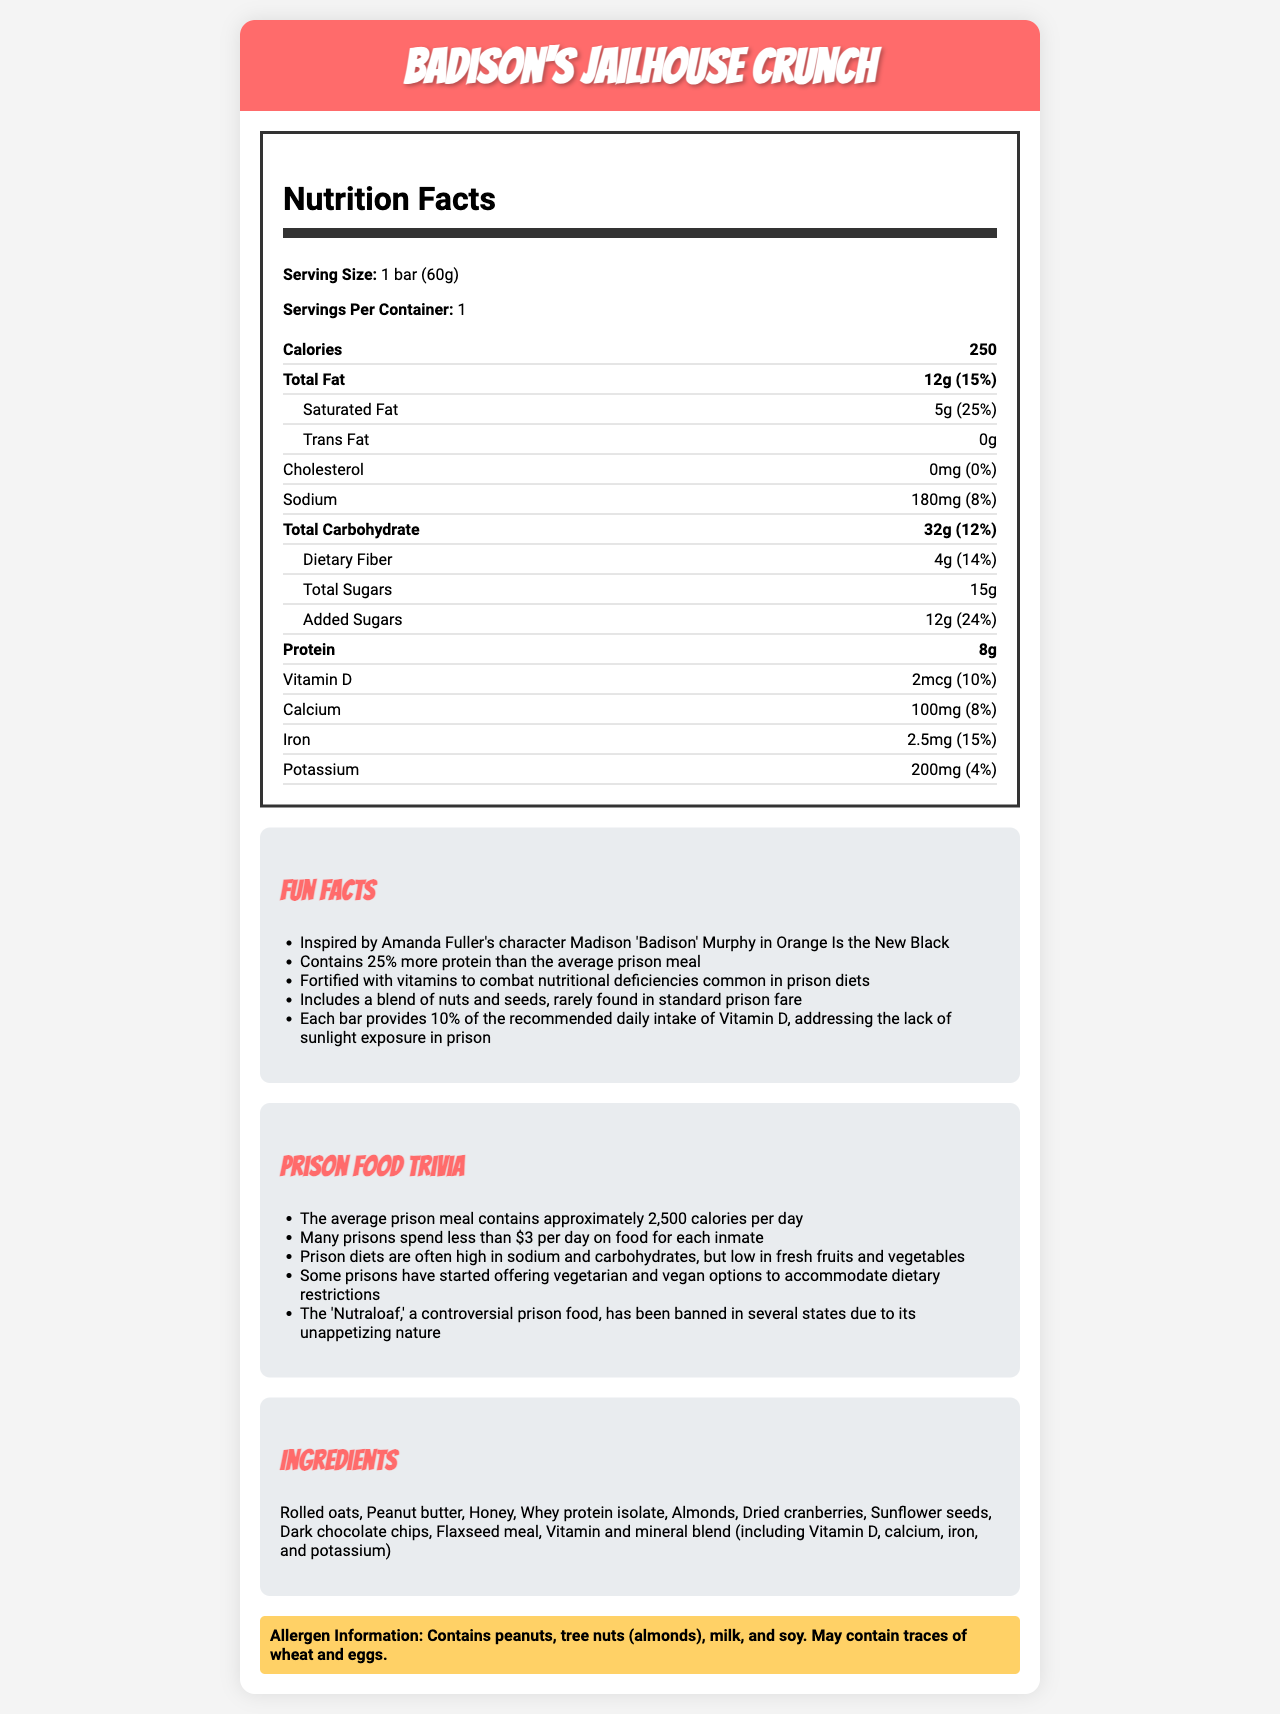what is the serving size of Badison's Jailhouse Crunch? The document states that the serving size is "1 bar (60g)".
Answer: 1 bar (60g) how many calories does each bar of Badison's Jailhouse Crunch have? The nutrition facts section lists the calorie content as 250.
Answer: 250 what percentage of the daily value is the saturated fat content? The nutrition facts indicate that the saturated fat content is 5g, which is 25% of the daily value.
Answer: 25% which ingredient is mentioned first in the ingredient list? The ingredients section lists "Rolled oats" first.
Answer: Rolled oats does Badison's Jailhouse Crunch contain any allergens? The allergen information at the end of the document states that it contains peanuts, tree nuts (almonds), milk, and soy.
Answer: Yes how much dietary fiber is in each serving? The document notes that each serving contains 4g of dietary fiber.
Answer: 4g which nutrient is present in the highest amount per serving: sodium, calcium, or potassium? According to the nutrition facts, sodium amounts to 180mg, whereas calcium is 100mg and potassium is 200mg. The explanation would be incorrect, Potassium is higher).
Answer: Sodium how much of the daily value of vitamin D does each bar provide? The nutrition facts indicate that each bar provides 2mcg of Vitamin D, equivalent to 10% of the daily value.
Answer: 10% what type of fats are absent in Badison's Jailhouse Crunch? The nutrition facts specifically state that there are 0g of trans fat.
Answer: Trans fat summary the main idea of the document. This is evident from the various sections of the document that provide nutritional values, ingredients, and trivia on prison diets.
Answer: Badison's Jailhouse Crunch is an energy bar inspired by Amanda Fuller's character in Orange Is the New Black. It provides detailed nutritional information, lists ingredients, and highlights fun facts and trivia related to prison diets, including insights into its protein, vitamins, and rare ingredients added to improve upon typical prison food nutrition. which of the following facts about prison diets is mentioned in the trivia section? I. Prison meals are high in sodium II. Many prisons spend less than $3 per day on food III. Fresh fruits and vegetables are commonly included A. I & II B. II & III C. I & III The trivia section mentions that prison diets are often high in sodium and that many prisons spend less than $3 per day on food.
Answer: A which nutrient aims to address the lack of sunlight exposure in prison? A. Vitamin C B. Vitamin D C. Calcium D. Iron One fun fact specifies that the bar provides 10% of the recommended daily intake of Vitamin D, addressing the lack of sunlight exposure in prison.
Answer: B is there any cholesterol in Badison's Jailhouse Crunch? The nutrition facts indicate that the cholesterol content is 0mg.
Answer: No how many uncanny things are listed about prison food trivia? The trivia section lists five specific facts about prison diets.
Answer: Five what is the total amount of sugars in each bar, combining both total and added sugars? The document shows 15g total sugars and specifies that 12g of them are added sugars.
Answer: 15g total sugars with 12g added sugars how many protein does each bar contain compared to an average prison meal? One fun fact indicates that each bar contains 25% more protein than the average prison meal.
Answer: 25% more protein how much money is spent per day on food for each inmate according to the trivia section? The document provides trivia saying "Many prisons spend less than $3 per day on food for each inmate," but it does not give an exact amount.
Answer: Cannot be determined 